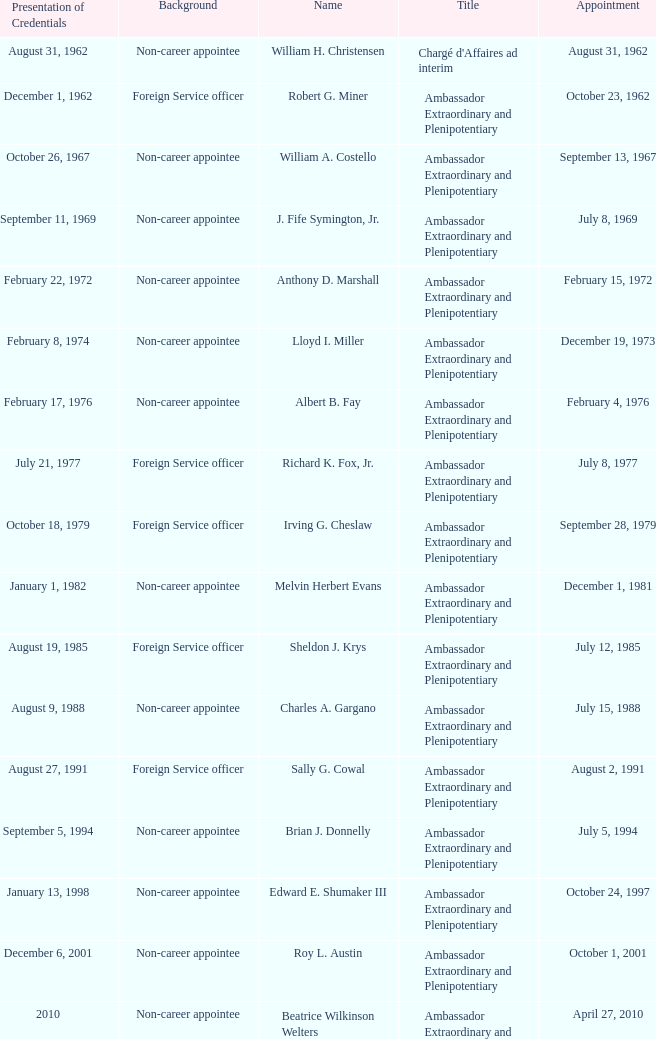When was William A. Costello appointed? September 13, 1967. 